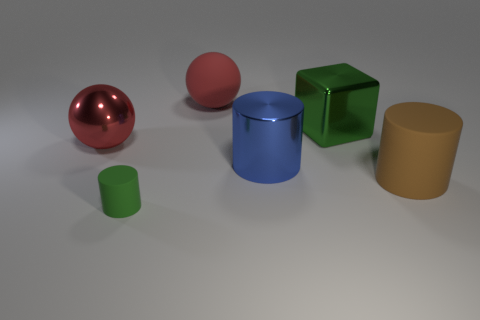Subtract all red spheres. How many were subtracted if there are1red spheres left? 1 Subtract all matte cylinders. How many cylinders are left? 1 Add 2 tiny rubber objects. How many objects exist? 8 Subtract all blue cylinders. How many cylinders are left? 2 Subtract 1 cylinders. How many cylinders are left? 2 Subtract all spheres. How many objects are left? 4 Subtract 0 green balls. How many objects are left? 6 Subtract all yellow spheres. Subtract all cyan cylinders. How many spheres are left? 2 Subtract all blue metallic cylinders. Subtract all big metal objects. How many objects are left? 2 Add 2 large green cubes. How many large green cubes are left? 3 